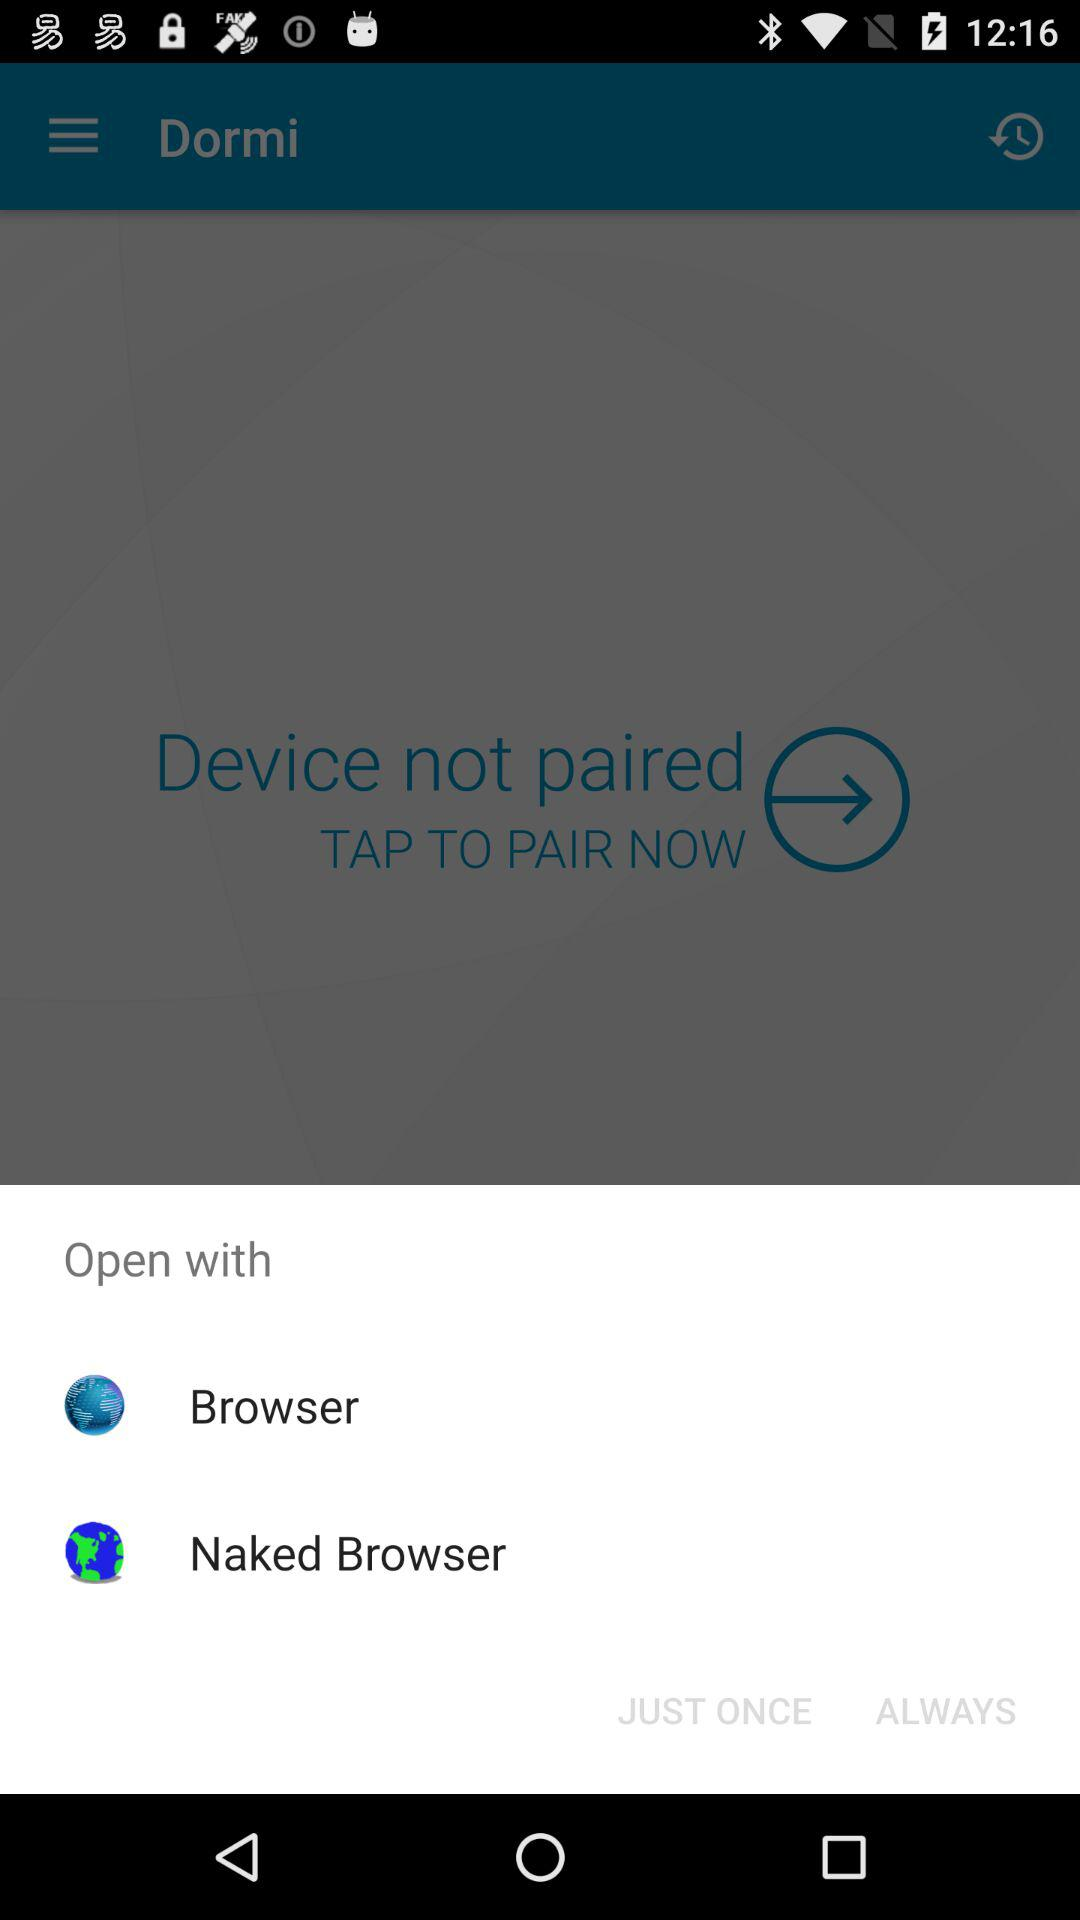What is the name of the device that is paired?
When the provided information is insufficient, respond with <no answer>. <no answer> 